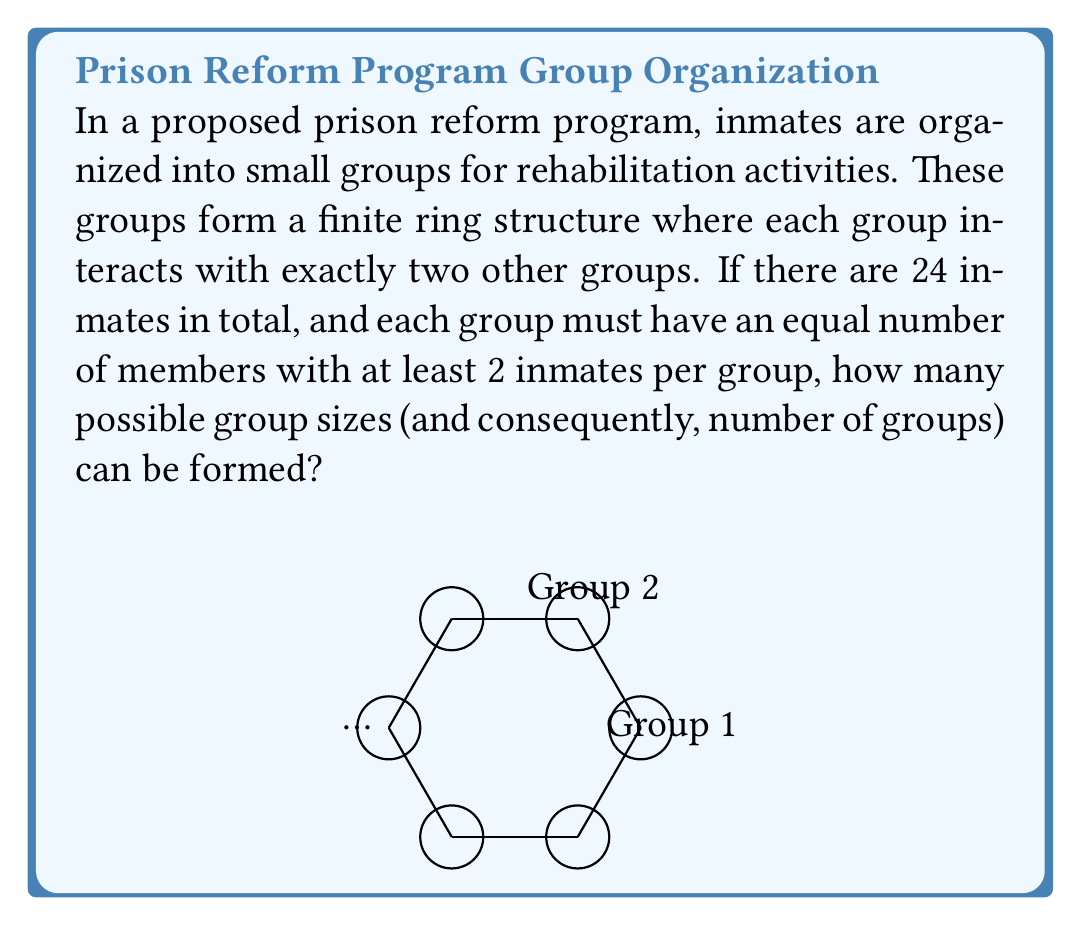Help me with this question. To solve this problem, we need to find the number of ways to divide 24 inmates into equal-sized groups, where each group forms a unit in a finite ring. Let's approach this step-by-step:

1) In a finite ring, the number of units (groups in this case) must be a factor of the total number of elements (inmates).

2) The factors of 24 are: 1, 2, 3, 4, 6, 8, 12, and 24.

3) However, we need to consider the constraints:
   - Each group must have at least 2 inmates
   - The number of groups must be at least 3 for a ring structure

4) Let's calculate the number of inmates per group for each factor:
   - 24 groups: 24 / 24 = 1 inmate per group (not allowed)
   - 12 groups: 24 / 12 = 2 inmates per group
   - 8 groups: 24 / 8 = 3 inmates per group
   - 6 groups: 24 / 6 = 4 inmates per group
   - 4 groups: 24 / 4 = 6 inmates per group
   - 3 groups: 24 / 3 = 8 inmates per group
   - 2 groups: 24 / 2 = 12 inmates per group (not a ring)
   - 1 group: 24 / 1 = 24 inmates per group (not a ring)

5) Counting the valid options, we have 5 possible group sizes: 2, 3, 4, 6, and 8 inmates per group.

Therefore, there are 5 possible ways to organize the inmates into groups that form a finite ring structure.
Answer: 5 